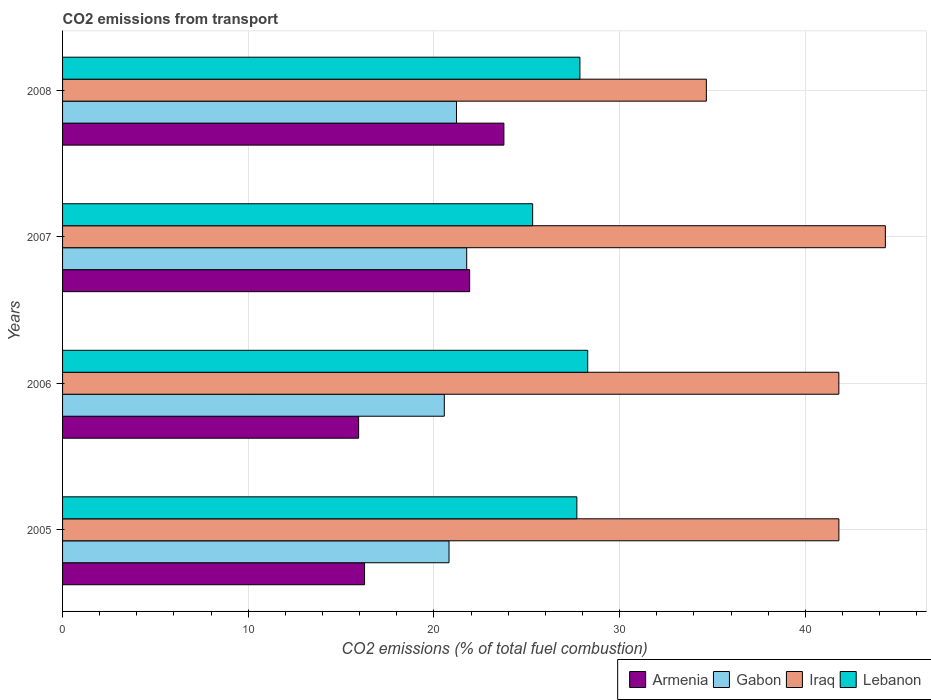Are the number of bars on each tick of the Y-axis equal?
Give a very brief answer. Yes. How many bars are there on the 1st tick from the top?
Your response must be concise. 4. In how many cases, is the number of bars for a given year not equal to the number of legend labels?
Offer a terse response. 0. What is the total CO2 emitted in Gabon in 2007?
Provide a succinct answer. 21.76. Across all years, what is the maximum total CO2 emitted in Iraq?
Your response must be concise. 44.31. Across all years, what is the minimum total CO2 emitted in Gabon?
Offer a very short reply. 20.56. In which year was the total CO2 emitted in Lebanon maximum?
Make the answer very short. 2006. In which year was the total CO2 emitted in Armenia minimum?
Your answer should be very brief. 2006. What is the total total CO2 emitted in Armenia in the graph?
Keep it short and to the point. 77.89. What is the difference between the total CO2 emitted in Gabon in 2005 and that in 2008?
Your answer should be compact. -0.4. What is the difference between the total CO2 emitted in Armenia in 2006 and the total CO2 emitted in Gabon in 2007?
Provide a succinct answer. -5.82. What is the average total CO2 emitted in Armenia per year?
Keep it short and to the point. 19.47. In the year 2008, what is the difference between the total CO2 emitted in Armenia and total CO2 emitted in Lebanon?
Keep it short and to the point. -4.09. In how many years, is the total CO2 emitted in Lebanon greater than 2 ?
Provide a succinct answer. 4. What is the ratio of the total CO2 emitted in Lebanon in 2005 to that in 2007?
Provide a succinct answer. 1.09. Is the total CO2 emitted in Armenia in 2007 less than that in 2008?
Give a very brief answer. Yes. Is the difference between the total CO2 emitted in Armenia in 2005 and 2007 greater than the difference between the total CO2 emitted in Lebanon in 2005 and 2007?
Offer a terse response. No. What is the difference between the highest and the second highest total CO2 emitted in Lebanon?
Make the answer very short. 0.42. What is the difference between the highest and the lowest total CO2 emitted in Armenia?
Keep it short and to the point. 7.82. In how many years, is the total CO2 emitted in Iraq greater than the average total CO2 emitted in Iraq taken over all years?
Your answer should be compact. 3. What does the 1st bar from the top in 2005 represents?
Give a very brief answer. Lebanon. What does the 1st bar from the bottom in 2005 represents?
Offer a terse response. Armenia. Is it the case that in every year, the sum of the total CO2 emitted in Armenia and total CO2 emitted in Gabon is greater than the total CO2 emitted in Lebanon?
Your response must be concise. Yes. How many bars are there?
Provide a succinct answer. 16. What is the difference between two consecutive major ticks on the X-axis?
Keep it short and to the point. 10. Does the graph contain grids?
Your answer should be very brief. Yes. How many legend labels are there?
Offer a very short reply. 4. How are the legend labels stacked?
Your answer should be compact. Horizontal. What is the title of the graph?
Your response must be concise. CO2 emissions from transport. What is the label or title of the X-axis?
Make the answer very short. CO2 emissions (% of total fuel combustion). What is the label or title of the Y-axis?
Provide a short and direct response. Years. What is the CO2 emissions (% of total fuel combustion) in Armenia in 2005?
Offer a very short reply. 16.26. What is the CO2 emissions (% of total fuel combustion) of Gabon in 2005?
Provide a succinct answer. 20.81. What is the CO2 emissions (% of total fuel combustion) of Iraq in 2005?
Make the answer very short. 41.8. What is the CO2 emissions (% of total fuel combustion) of Lebanon in 2005?
Offer a very short reply. 27.69. What is the CO2 emissions (% of total fuel combustion) of Armenia in 2006?
Offer a very short reply. 15.94. What is the CO2 emissions (% of total fuel combustion) of Gabon in 2006?
Your answer should be compact. 20.56. What is the CO2 emissions (% of total fuel combustion) of Iraq in 2006?
Provide a short and direct response. 41.8. What is the CO2 emissions (% of total fuel combustion) of Lebanon in 2006?
Offer a terse response. 28.28. What is the CO2 emissions (% of total fuel combustion) in Armenia in 2007?
Your answer should be compact. 21.92. What is the CO2 emissions (% of total fuel combustion) of Gabon in 2007?
Ensure brevity in your answer.  21.76. What is the CO2 emissions (% of total fuel combustion) in Iraq in 2007?
Give a very brief answer. 44.31. What is the CO2 emissions (% of total fuel combustion) of Lebanon in 2007?
Your response must be concise. 25.31. What is the CO2 emissions (% of total fuel combustion) of Armenia in 2008?
Make the answer very short. 23.76. What is the CO2 emissions (% of total fuel combustion) in Gabon in 2008?
Your answer should be very brief. 21.21. What is the CO2 emissions (% of total fuel combustion) of Iraq in 2008?
Your answer should be very brief. 34.67. What is the CO2 emissions (% of total fuel combustion) of Lebanon in 2008?
Provide a succinct answer. 27.86. Across all years, what is the maximum CO2 emissions (% of total fuel combustion) of Armenia?
Provide a short and direct response. 23.76. Across all years, what is the maximum CO2 emissions (% of total fuel combustion) in Gabon?
Offer a very short reply. 21.76. Across all years, what is the maximum CO2 emissions (% of total fuel combustion) in Iraq?
Offer a very short reply. 44.31. Across all years, what is the maximum CO2 emissions (% of total fuel combustion) in Lebanon?
Your answer should be very brief. 28.28. Across all years, what is the minimum CO2 emissions (% of total fuel combustion) of Armenia?
Offer a very short reply. 15.94. Across all years, what is the minimum CO2 emissions (% of total fuel combustion) of Gabon?
Your answer should be compact. 20.56. Across all years, what is the minimum CO2 emissions (% of total fuel combustion) of Iraq?
Your answer should be very brief. 34.67. Across all years, what is the minimum CO2 emissions (% of total fuel combustion) in Lebanon?
Your response must be concise. 25.31. What is the total CO2 emissions (% of total fuel combustion) in Armenia in the graph?
Your answer should be very brief. 77.89. What is the total CO2 emissions (% of total fuel combustion) of Gabon in the graph?
Provide a succinct answer. 84.34. What is the total CO2 emissions (% of total fuel combustion) of Iraq in the graph?
Keep it short and to the point. 162.58. What is the total CO2 emissions (% of total fuel combustion) of Lebanon in the graph?
Ensure brevity in your answer.  109.14. What is the difference between the CO2 emissions (% of total fuel combustion) in Armenia in 2005 and that in 2006?
Your answer should be compact. 0.32. What is the difference between the CO2 emissions (% of total fuel combustion) of Gabon in 2005 and that in 2006?
Give a very brief answer. 0.25. What is the difference between the CO2 emissions (% of total fuel combustion) of Iraq in 2005 and that in 2006?
Provide a succinct answer. 0. What is the difference between the CO2 emissions (% of total fuel combustion) of Lebanon in 2005 and that in 2006?
Your answer should be compact. -0.58. What is the difference between the CO2 emissions (% of total fuel combustion) in Armenia in 2005 and that in 2007?
Offer a very short reply. -5.66. What is the difference between the CO2 emissions (% of total fuel combustion) of Gabon in 2005 and that in 2007?
Keep it short and to the point. -0.95. What is the difference between the CO2 emissions (% of total fuel combustion) in Iraq in 2005 and that in 2007?
Provide a short and direct response. -2.5. What is the difference between the CO2 emissions (% of total fuel combustion) of Lebanon in 2005 and that in 2007?
Make the answer very short. 2.38. What is the difference between the CO2 emissions (% of total fuel combustion) of Armenia in 2005 and that in 2008?
Offer a terse response. -7.5. What is the difference between the CO2 emissions (% of total fuel combustion) of Gabon in 2005 and that in 2008?
Keep it short and to the point. -0.4. What is the difference between the CO2 emissions (% of total fuel combustion) of Iraq in 2005 and that in 2008?
Your response must be concise. 7.14. What is the difference between the CO2 emissions (% of total fuel combustion) of Lebanon in 2005 and that in 2008?
Your answer should be very brief. -0.17. What is the difference between the CO2 emissions (% of total fuel combustion) of Armenia in 2006 and that in 2007?
Offer a terse response. -5.98. What is the difference between the CO2 emissions (% of total fuel combustion) of Gabon in 2006 and that in 2007?
Your answer should be compact. -1.21. What is the difference between the CO2 emissions (% of total fuel combustion) in Iraq in 2006 and that in 2007?
Provide a succinct answer. -2.5. What is the difference between the CO2 emissions (% of total fuel combustion) in Lebanon in 2006 and that in 2007?
Offer a terse response. 2.97. What is the difference between the CO2 emissions (% of total fuel combustion) in Armenia in 2006 and that in 2008?
Make the answer very short. -7.82. What is the difference between the CO2 emissions (% of total fuel combustion) of Gabon in 2006 and that in 2008?
Provide a succinct answer. -0.66. What is the difference between the CO2 emissions (% of total fuel combustion) of Iraq in 2006 and that in 2008?
Give a very brief answer. 7.13. What is the difference between the CO2 emissions (% of total fuel combustion) of Lebanon in 2006 and that in 2008?
Ensure brevity in your answer.  0.42. What is the difference between the CO2 emissions (% of total fuel combustion) in Armenia in 2007 and that in 2008?
Keep it short and to the point. -1.84. What is the difference between the CO2 emissions (% of total fuel combustion) in Gabon in 2007 and that in 2008?
Offer a terse response. 0.55. What is the difference between the CO2 emissions (% of total fuel combustion) of Iraq in 2007 and that in 2008?
Give a very brief answer. 9.64. What is the difference between the CO2 emissions (% of total fuel combustion) of Lebanon in 2007 and that in 2008?
Give a very brief answer. -2.55. What is the difference between the CO2 emissions (% of total fuel combustion) in Armenia in 2005 and the CO2 emissions (% of total fuel combustion) in Gabon in 2006?
Your response must be concise. -4.29. What is the difference between the CO2 emissions (% of total fuel combustion) in Armenia in 2005 and the CO2 emissions (% of total fuel combustion) in Iraq in 2006?
Offer a terse response. -25.54. What is the difference between the CO2 emissions (% of total fuel combustion) in Armenia in 2005 and the CO2 emissions (% of total fuel combustion) in Lebanon in 2006?
Make the answer very short. -12.02. What is the difference between the CO2 emissions (% of total fuel combustion) in Gabon in 2005 and the CO2 emissions (% of total fuel combustion) in Iraq in 2006?
Your response must be concise. -20.99. What is the difference between the CO2 emissions (% of total fuel combustion) in Gabon in 2005 and the CO2 emissions (% of total fuel combustion) in Lebanon in 2006?
Ensure brevity in your answer.  -7.47. What is the difference between the CO2 emissions (% of total fuel combustion) in Iraq in 2005 and the CO2 emissions (% of total fuel combustion) in Lebanon in 2006?
Keep it short and to the point. 13.52. What is the difference between the CO2 emissions (% of total fuel combustion) in Armenia in 2005 and the CO2 emissions (% of total fuel combustion) in Gabon in 2007?
Your response must be concise. -5.5. What is the difference between the CO2 emissions (% of total fuel combustion) of Armenia in 2005 and the CO2 emissions (% of total fuel combustion) of Iraq in 2007?
Your answer should be very brief. -28.04. What is the difference between the CO2 emissions (% of total fuel combustion) in Armenia in 2005 and the CO2 emissions (% of total fuel combustion) in Lebanon in 2007?
Your answer should be compact. -9.05. What is the difference between the CO2 emissions (% of total fuel combustion) of Gabon in 2005 and the CO2 emissions (% of total fuel combustion) of Iraq in 2007?
Offer a very short reply. -23.5. What is the difference between the CO2 emissions (% of total fuel combustion) in Gabon in 2005 and the CO2 emissions (% of total fuel combustion) in Lebanon in 2007?
Provide a short and direct response. -4.5. What is the difference between the CO2 emissions (% of total fuel combustion) of Iraq in 2005 and the CO2 emissions (% of total fuel combustion) of Lebanon in 2007?
Keep it short and to the point. 16.49. What is the difference between the CO2 emissions (% of total fuel combustion) of Armenia in 2005 and the CO2 emissions (% of total fuel combustion) of Gabon in 2008?
Keep it short and to the point. -4.95. What is the difference between the CO2 emissions (% of total fuel combustion) in Armenia in 2005 and the CO2 emissions (% of total fuel combustion) in Iraq in 2008?
Keep it short and to the point. -18.4. What is the difference between the CO2 emissions (% of total fuel combustion) in Armenia in 2005 and the CO2 emissions (% of total fuel combustion) in Lebanon in 2008?
Keep it short and to the point. -11.6. What is the difference between the CO2 emissions (% of total fuel combustion) of Gabon in 2005 and the CO2 emissions (% of total fuel combustion) of Iraq in 2008?
Your response must be concise. -13.86. What is the difference between the CO2 emissions (% of total fuel combustion) in Gabon in 2005 and the CO2 emissions (% of total fuel combustion) in Lebanon in 2008?
Ensure brevity in your answer.  -7.05. What is the difference between the CO2 emissions (% of total fuel combustion) in Iraq in 2005 and the CO2 emissions (% of total fuel combustion) in Lebanon in 2008?
Ensure brevity in your answer.  13.94. What is the difference between the CO2 emissions (% of total fuel combustion) in Armenia in 2006 and the CO2 emissions (% of total fuel combustion) in Gabon in 2007?
Provide a short and direct response. -5.82. What is the difference between the CO2 emissions (% of total fuel combustion) of Armenia in 2006 and the CO2 emissions (% of total fuel combustion) of Iraq in 2007?
Make the answer very short. -28.36. What is the difference between the CO2 emissions (% of total fuel combustion) of Armenia in 2006 and the CO2 emissions (% of total fuel combustion) of Lebanon in 2007?
Provide a short and direct response. -9.37. What is the difference between the CO2 emissions (% of total fuel combustion) in Gabon in 2006 and the CO2 emissions (% of total fuel combustion) in Iraq in 2007?
Offer a terse response. -23.75. What is the difference between the CO2 emissions (% of total fuel combustion) in Gabon in 2006 and the CO2 emissions (% of total fuel combustion) in Lebanon in 2007?
Offer a very short reply. -4.76. What is the difference between the CO2 emissions (% of total fuel combustion) in Iraq in 2006 and the CO2 emissions (% of total fuel combustion) in Lebanon in 2007?
Offer a very short reply. 16.49. What is the difference between the CO2 emissions (% of total fuel combustion) of Armenia in 2006 and the CO2 emissions (% of total fuel combustion) of Gabon in 2008?
Your answer should be very brief. -5.27. What is the difference between the CO2 emissions (% of total fuel combustion) in Armenia in 2006 and the CO2 emissions (% of total fuel combustion) in Iraq in 2008?
Your answer should be compact. -18.72. What is the difference between the CO2 emissions (% of total fuel combustion) of Armenia in 2006 and the CO2 emissions (% of total fuel combustion) of Lebanon in 2008?
Provide a succinct answer. -11.92. What is the difference between the CO2 emissions (% of total fuel combustion) in Gabon in 2006 and the CO2 emissions (% of total fuel combustion) in Iraq in 2008?
Your answer should be very brief. -14.11. What is the difference between the CO2 emissions (% of total fuel combustion) in Gabon in 2006 and the CO2 emissions (% of total fuel combustion) in Lebanon in 2008?
Your response must be concise. -7.3. What is the difference between the CO2 emissions (% of total fuel combustion) in Iraq in 2006 and the CO2 emissions (% of total fuel combustion) in Lebanon in 2008?
Your response must be concise. 13.94. What is the difference between the CO2 emissions (% of total fuel combustion) of Armenia in 2007 and the CO2 emissions (% of total fuel combustion) of Gabon in 2008?
Provide a short and direct response. 0.71. What is the difference between the CO2 emissions (% of total fuel combustion) of Armenia in 2007 and the CO2 emissions (% of total fuel combustion) of Iraq in 2008?
Your answer should be compact. -12.75. What is the difference between the CO2 emissions (% of total fuel combustion) in Armenia in 2007 and the CO2 emissions (% of total fuel combustion) in Lebanon in 2008?
Provide a succinct answer. -5.94. What is the difference between the CO2 emissions (% of total fuel combustion) of Gabon in 2007 and the CO2 emissions (% of total fuel combustion) of Iraq in 2008?
Offer a very short reply. -12.9. What is the difference between the CO2 emissions (% of total fuel combustion) in Gabon in 2007 and the CO2 emissions (% of total fuel combustion) in Lebanon in 2008?
Your answer should be compact. -6.1. What is the difference between the CO2 emissions (% of total fuel combustion) in Iraq in 2007 and the CO2 emissions (% of total fuel combustion) in Lebanon in 2008?
Keep it short and to the point. 16.45. What is the average CO2 emissions (% of total fuel combustion) in Armenia per year?
Keep it short and to the point. 19.47. What is the average CO2 emissions (% of total fuel combustion) in Gabon per year?
Provide a short and direct response. 21.08. What is the average CO2 emissions (% of total fuel combustion) of Iraq per year?
Offer a very short reply. 40.64. What is the average CO2 emissions (% of total fuel combustion) of Lebanon per year?
Provide a short and direct response. 27.29. In the year 2005, what is the difference between the CO2 emissions (% of total fuel combustion) in Armenia and CO2 emissions (% of total fuel combustion) in Gabon?
Provide a succinct answer. -4.55. In the year 2005, what is the difference between the CO2 emissions (% of total fuel combustion) of Armenia and CO2 emissions (% of total fuel combustion) of Iraq?
Provide a succinct answer. -25.54. In the year 2005, what is the difference between the CO2 emissions (% of total fuel combustion) in Armenia and CO2 emissions (% of total fuel combustion) in Lebanon?
Make the answer very short. -11.43. In the year 2005, what is the difference between the CO2 emissions (% of total fuel combustion) in Gabon and CO2 emissions (% of total fuel combustion) in Iraq?
Offer a terse response. -20.99. In the year 2005, what is the difference between the CO2 emissions (% of total fuel combustion) of Gabon and CO2 emissions (% of total fuel combustion) of Lebanon?
Provide a short and direct response. -6.88. In the year 2005, what is the difference between the CO2 emissions (% of total fuel combustion) of Iraq and CO2 emissions (% of total fuel combustion) of Lebanon?
Offer a very short reply. 14.11. In the year 2006, what is the difference between the CO2 emissions (% of total fuel combustion) of Armenia and CO2 emissions (% of total fuel combustion) of Gabon?
Keep it short and to the point. -4.61. In the year 2006, what is the difference between the CO2 emissions (% of total fuel combustion) in Armenia and CO2 emissions (% of total fuel combustion) in Iraq?
Your response must be concise. -25.86. In the year 2006, what is the difference between the CO2 emissions (% of total fuel combustion) of Armenia and CO2 emissions (% of total fuel combustion) of Lebanon?
Give a very brief answer. -12.34. In the year 2006, what is the difference between the CO2 emissions (% of total fuel combustion) of Gabon and CO2 emissions (% of total fuel combustion) of Iraq?
Your answer should be compact. -21.25. In the year 2006, what is the difference between the CO2 emissions (% of total fuel combustion) of Gabon and CO2 emissions (% of total fuel combustion) of Lebanon?
Your answer should be compact. -7.72. In the year 2006, what is the difference between the CO2 emissions (% of total fuel combustion) in Iraq and CO2 emissions (% of total fuel combustion) in Lebanon?
Offer a very short reply. 13.52. In the year 2007, what is the difference between the CO2 emissions (% of total fuel combustion) in Armenia and CO2 emissions (% of total fuel combustion) in Gabon?
Keep it short and to the point. 0.16. In the year 2007, what is the difference between the CO2 emissions (% of total fuel combustion) in Armenia and CO2 emissions (% of total fuel combustion) in Iraq?
Ensure brevity in your answer.  -22.38. In the year 2007, what is the difference between the CO2 emissions (% of total fuel combustion) in Armenia and CO2 emissions (% of total fuel combustion) in Lebanon?
Provide a short and direct response. -3.39. In the year 2007, what is the difference between the CO2 emissions (% of total fuel combustion) of Gabon and CO2 emissions (% of total fuel combustion) of Iraq?
Keep it short and to the point. -22.54. In the year 2007, what is the difference between the CO2 emissions (% of total fuel combustion) of Gabon and CO2 emissions (% of total fuel combustion) of Lebanon?
Keep it short and to the point. -3.55. In the year 2007, what is the difference between the CO2 emissions (% of total fuel combustion) in Iraq and CO2 emissions (% of total fuel combustion) in Lebanon?
Ensure brevity in your answer.  18.99. In the year 2008, what is the difference between the CO2 emissions (% of total fuel combustion) in Armenia and CO2 emissions (% of total fuel combustion) in Gabon?
Provide a short and direct response. 2.55. In the year 2008, what is the difference between the CO2 emissions (% of total fuel combustion) in Armenia and CO2 emissions (% of total fuel combustion) in Iraq?
Offer a very short reply. -10.9. In the year 2008, what is the difference between the CO2 emissions (% of total fuel combustion) of Armenia and CO2 emissions (% of total fuel combustion) of Lebanon?
Make the answer very short. -4.09. In the year 2008, what is the difference between the CO2 emissions (% of total fuel combustion) of Gabon and CO2 emissions (% of total fuel combustion) of Iraq?
Offer a terse response. -13.45. In the year 2008, what is the difference between the CO2 emissions (% of total fuel combustion) of Gabon and CO2 emissions (% of total fuel combustion) of Lebanon?
Give a very brief answer. -6.65. In the year 2008, what is the difference between the CO2 emissions (% of total fuel combustion) in Iraq and CO2 emissions (% of total fuel combustion) in Lebanon?
Provide a short and direct response. 6.81. What is the ratio of the CO2 emissions (% of total fuel combustion) in Armenia in 2005 to that in 2006?
Provide a succinct answer. 1.02. What is the ratio of the CO2 emissions (% of total fuel combustion) of Gabon in 2005 to that in 2006?
Your answer should be very brief. 1.01. What is the ratio of the CO2 emissions (% of total fuel combustion) of Iraq in 2005 to that in 2006?
Ensure brevity in your answer.  1. What is the ratio of the CO2 emissions (% of total fuel combustion) of Lebanon in 2005 to that in 2006?
Provide a short and direct response. 0.98. What is the ratio of the CO2 emissions (% of total fuel combustion) of Armenia in 2005 to that in 2007?
Offer a very short reply. 0.74. What is the ratio of the CO2 emissions (% of total fuel combustion) of Gabon in 2005 to that in 2007?
Offer a very short reply. 0.96. What is the ratio of the CO2 emissions (% of total fuel combustion) of Iraq in 2005 to that in 2007?
Offer a very short reply. 0.94. What is the ratio of the CO2 emissions (% of total fuel combustion) of Lebanon in 2005 to that in 2007?
Offer a terse response. 1.09. What is the ratio of the CO2 emissions (% of total fuel combustion) in Armenia in 2005 to that in 2008?
Keep it short and to the point. 0.68. What is the ratio of the CO2 emissions (% of total fuel combustion) in Iraq in 2005 to that in 2008?
Ensure brevity in your answer.  1.21. What is the ratio of the CO2 emissions (% of total fuel combustion) in Lebanon in 2005 to that in 2008?
Your response must be concise. 0.99. What is the ratio of the CO2 emissions (% of total fuel combustion) of Armenia in 2006 to that in 2007?
Offer a very short reply. 0.73. What is the ratio of the CO2 emissions (% of total fuel combustion) of Gabon in 2006 to that in 2007?
Ensure brevity in your answer.  0.94. What is the ratio of the CO2 emissions (% of total fuel combustion) in Iraq in 2006 to that in 2007?
Your response must be concise. 0.94. What is the ratio of the CO2 emissions (% of total fuel combustion) in Lebanon in 2006 to that in 2007?
Make the answer very short. 1.12. What is the ratio of the CO2 emissions (% of total fuel combustion) of Armenia in 2006 to that in 2008?
Ensure brevity in your answer.  0.67. What is the ratio of the CO2 emissions (% of total fuel combustion) of Iraq in 2006 to that in 2008?
Your response must be concise. 1.21. What is the ratio of the CO2 emissions (% of total fuel combustion) in Lebanon in 2006 to that in 2008?
Provide a short and direct response. 1.02. What is the ratio of the CO2 emissions (% of total fuel combustion) in Armenia in 2007 to that in 2008?
Ensure brevity in your answer.  0.92. What is the ratio of the CO2 emissions (% of total fuel combustion) of Gabon in 2007 to that in 2008?
Provide a succinct answer. 1.03. What is the ratio of the CO2 emissions (% of total fuel combustion) in Iraq in 2007 to that in 2008?
Provide a succinct answer. 1.28. What is the ratio of the CO2 emissions (% of total fuel combustion) of Lebanon in 2007 to that in 2008?
Keep it short and to the point. 0.91. What is the difference between the highest and the second highest CO2 emissions (% of total fuel combustion) in Armenia?
Give a very brief answer. 1.84. What is the difference between the highest and the second highest CO2 emissions (% of total fuel combustion) of Gabon?
Your response must be concise. 0.55. What is the difference between the highest and the second highest CO2 emissions (% of total fuel combustion) in Iraq?
Your answer should be very brief. 2.5. What is the difference between the highest and the second highest CO2 emissions (% of total fuel combustion) of Lebanon?
Your answer should be compact. 0.42. What is the difference between the highest and the lowest CO2 emissions (% of total fuel combustion) in Armenia?
Provide a succinct answer. 7.82. What is the difference between the highest and the lowest CO2 emissions (% of total fuel combustion) of Gabon?
Offer a very short reply. 1.21. What is the difference between the highest and the lowest CO2 emissions (% of total fuel combustion) of Iraq?
Your answer should be very brief. 9.64. What is the difference between the highest and the lowest CO2 emissions (% of total fuel combustion) of Lebanon?
Offer a very short reply. 2.97. 